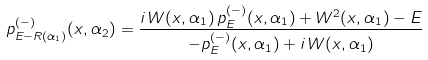<formula> <loc_0><loc_0><loc_500><loc_500>p ^ { ( - ) } _ { E - R ( \alpha _ { 1 } ) } ( x , \alpha _ { 2 } ) = \frac { i \, W ( x , \alpha _ { 1 } ) \, p ^ { ( - ) } _ { E } ( x , \alpha _ { 1 } ) + W ^ { 2 } ( x , \alpha _ { 1 } ) - E } { - p ^ { ( - ) } _ { E } ( x , \alpha _ { 1 } ) + i \, W ( x , \alpha _ { 1 } ) }</formula> 